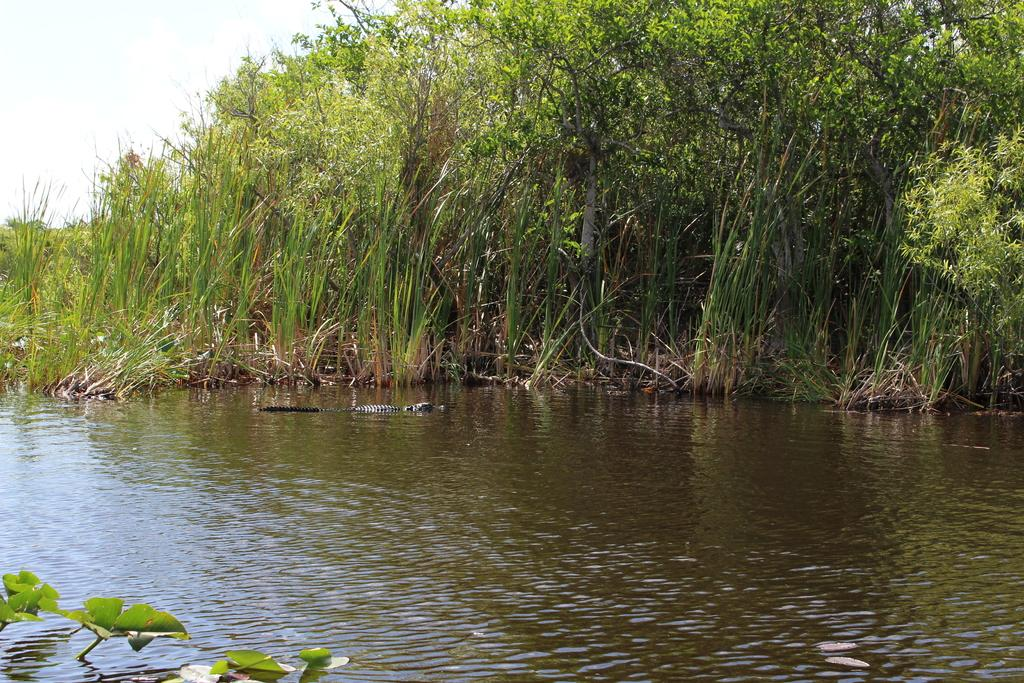What is the primary element visible in the image? There is a large amount of water in the image. What can be seen beside the water in the image? There are plants visible beside the water in the image. What type of religion is being practiced by the roll and brothers in the image? There is no roll or brothers present in the image, nor is there any indication of a religious practice. 